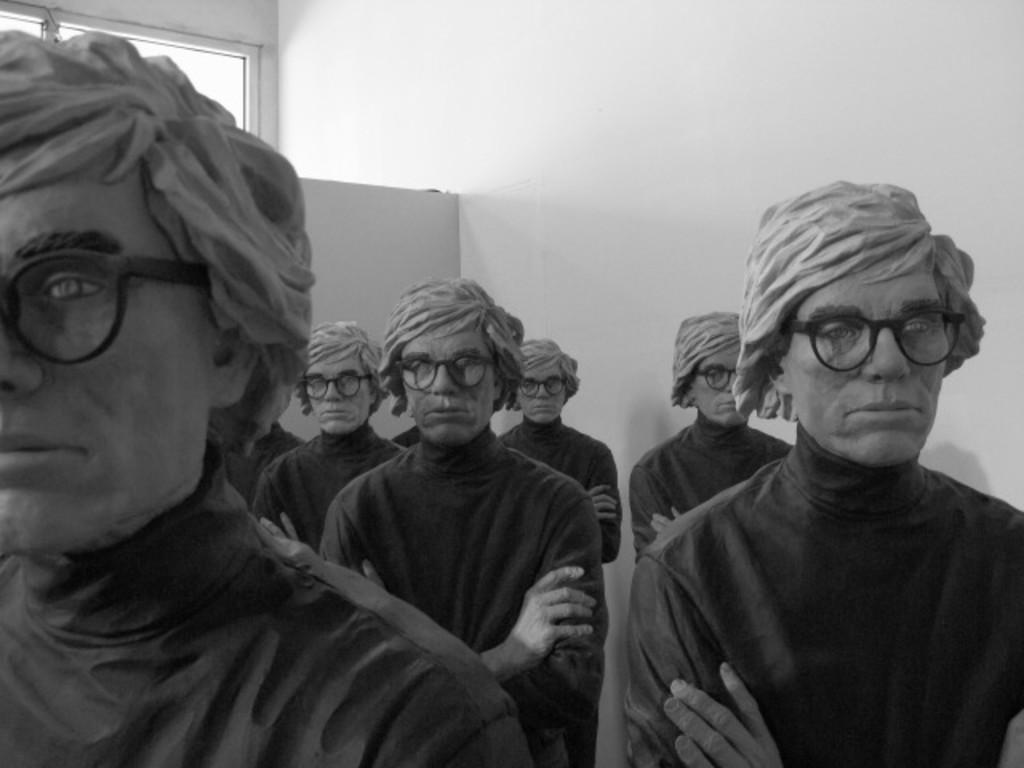What is the main subject in the foreground of the image? There are sculptures of men in the foreground of the image. What can be seen in the background of the image? There is a wall in the background of the image. Is there any opening in the wall visible in the image? Yes, there appears to be a window at the top of the image. How many fish are swimming in the water near the sculptures in the image? There are no fish or water present in the image; it features sculptures of men and a wall in the background. 